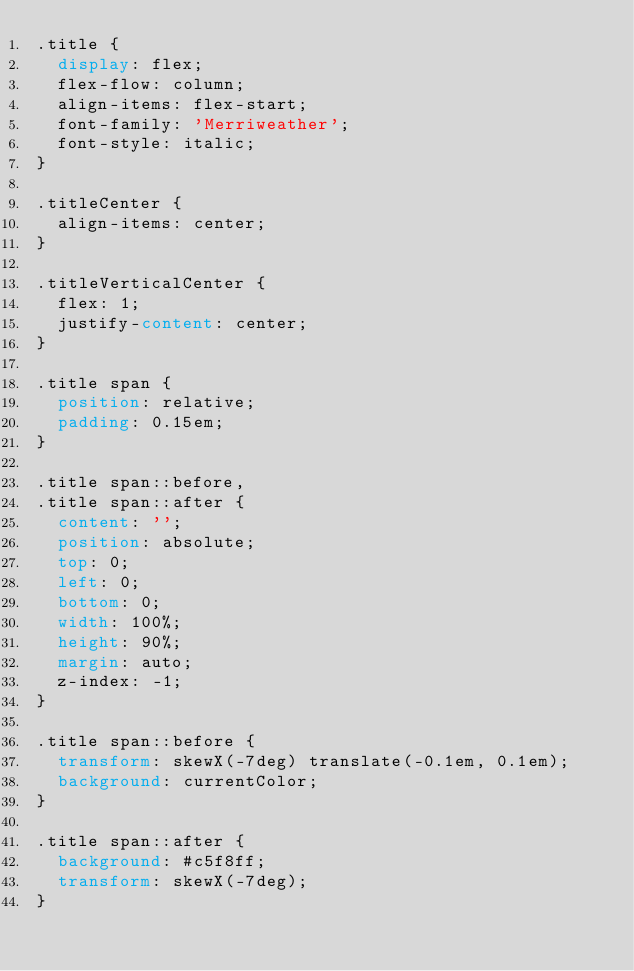<code> <loc_0><loc_0><loc_500><loc_500><_CSS_>.title {
  display: flex;
  flex-flow: column;
  align-items: flex-start;
  font-family: 'Merriweather';
  font-style: italic;
}

.titleCenter {
  align-items: center;
}

.titleVerticalCenter {
  flex: 1;
  justify-content: center;
}

.title span {
  position: relative;
  padding: 0.15em;
}

.title span::before,
.title span::after {
  content: '';
  position: absolute;
  top: 0;
  left: 0;
  bottom: 0;
  width: 100%;
  height: 90%;
  margin: auto;
  z-index: -1;
}

.title span::before {
  transform: skewX(-7deg) translate(-0.1em, 0.1em);
  background: currentColor;
}

.title span::after {
  background: #c5f8ff;
  transform: skewX(-7deg);
}
</code> 